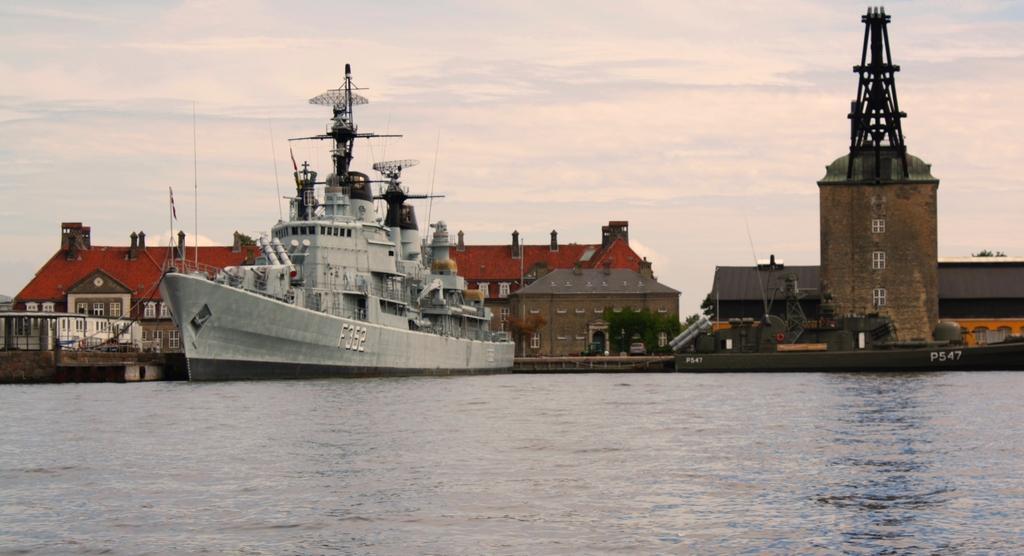Can you describe this image briefly? In this image we can see a ship on the water, there are some houses, plants, windows, poles, flags and a tower, also we can see the sky with clouds. 